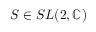<formula> <loc_0><loc_0><loc_500><loc_500>S \in S L ( 2 , \mathbb { C } )</formula> 